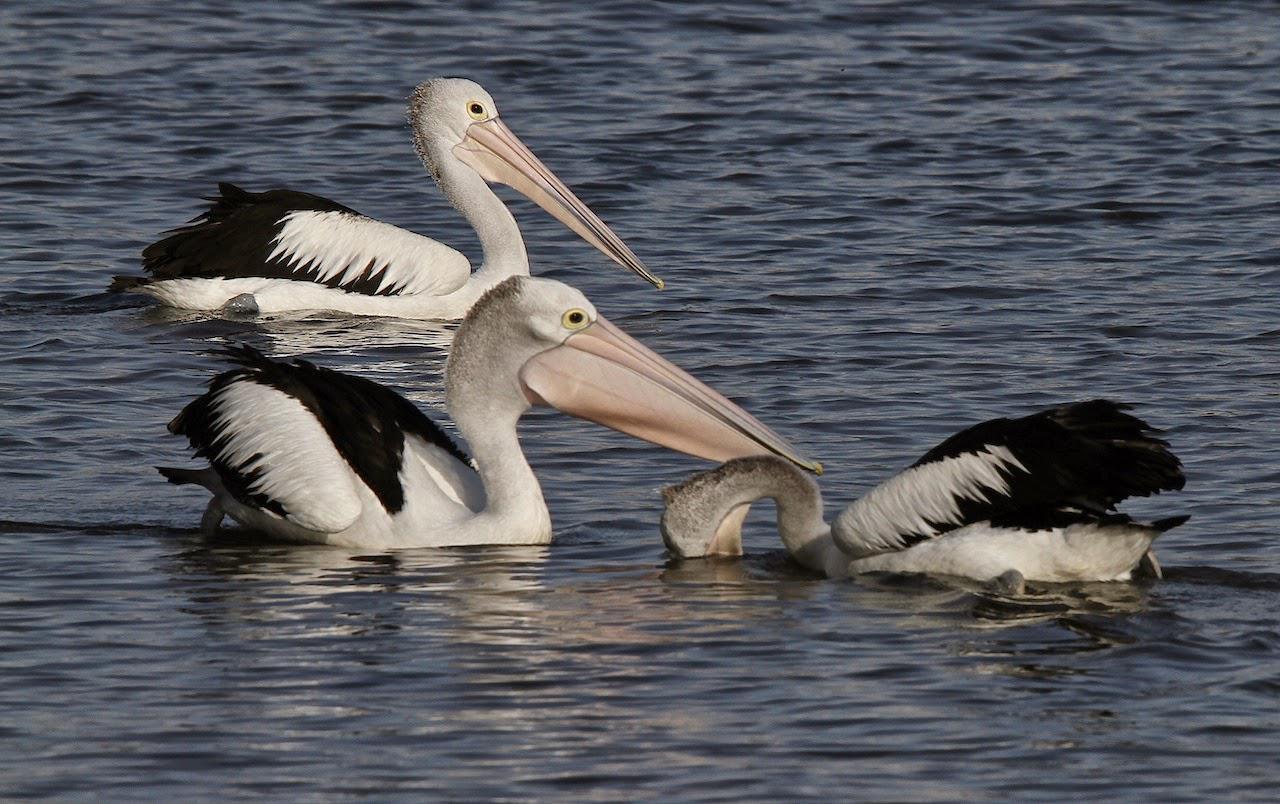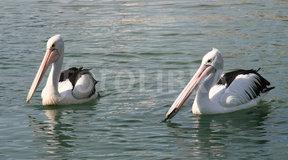The first image is the image on the left, the second image is the image on the right. Analyze the images presented: Is the assertion "All pelicans are on the water, one image contains exactly two pelicans, and each image contains no more than three pelicans." valid? Answer yes or no. Yes. The first image is the image on the left, the second image is the image on the right. Analyze the images presented: Is the assertion "There is no more than two birds in the left image." valid? Answer yes or no. No. 